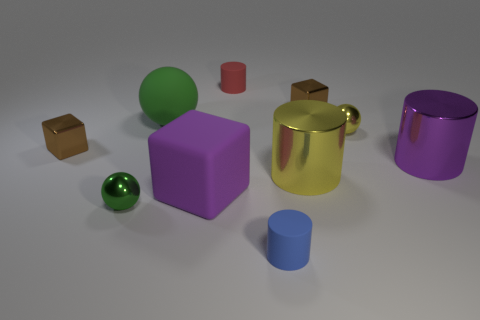Subtract all balls. How many objects are left? 7 Subtract all tiny brown metal objects. Subtract all blue cylinders. How many objects are left? 7 Add 3 green metallic spheres. How many green metallic spheres are left? 4 Add 3 green matte objects. How many green matte objects exist? 4 Subtract 1 red cylinders. How many objects are left? 9 